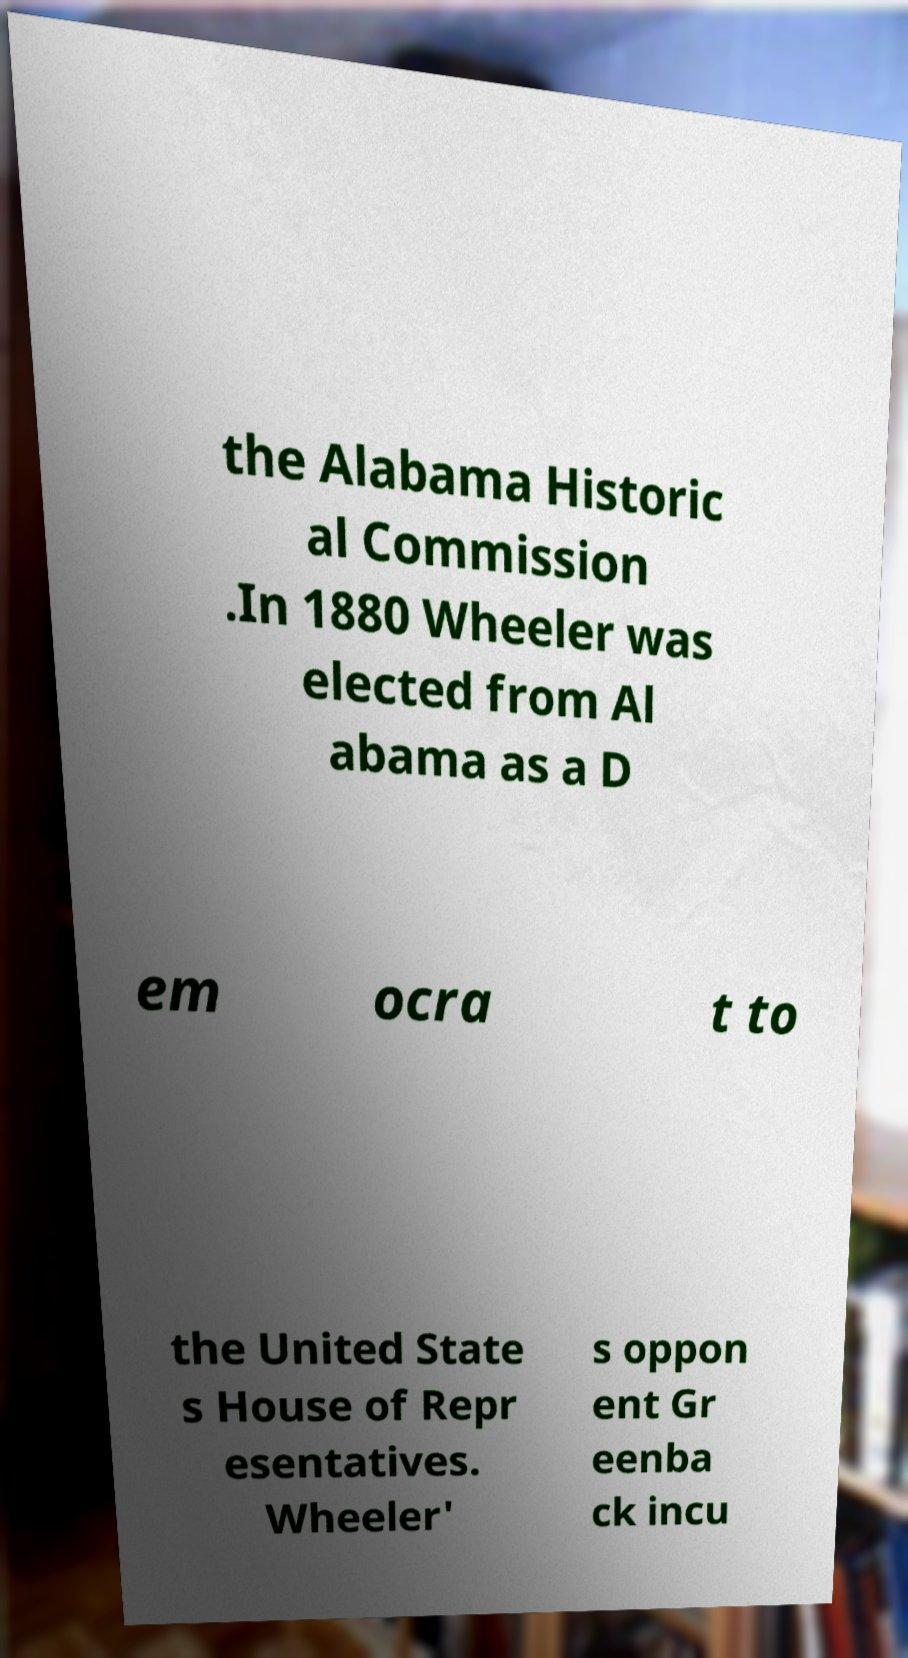For documentation purposes, I need the text within this image transcribed. Could you provide that? the Alabama Historic al Commission .In 1880 Wheeler was elected from Al abama as a D em ocra t to the United State s House of Repr esentatives. Wheeler' s oppon ent Gr eenba ck incu 